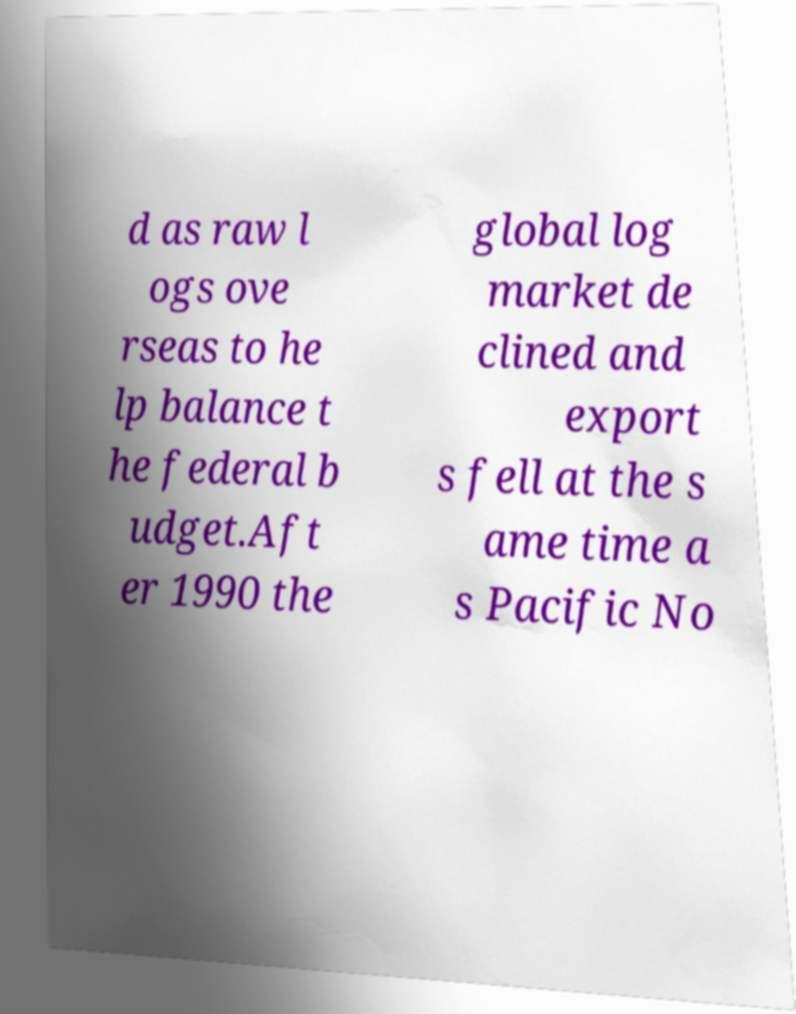Could you extract and type out the text from this image? d as raw l ogs ove rseas to he lp balance t he federal b udget.Aft er 1990 the global log market de clined and export s fell at the s ame time a s Pacific No 